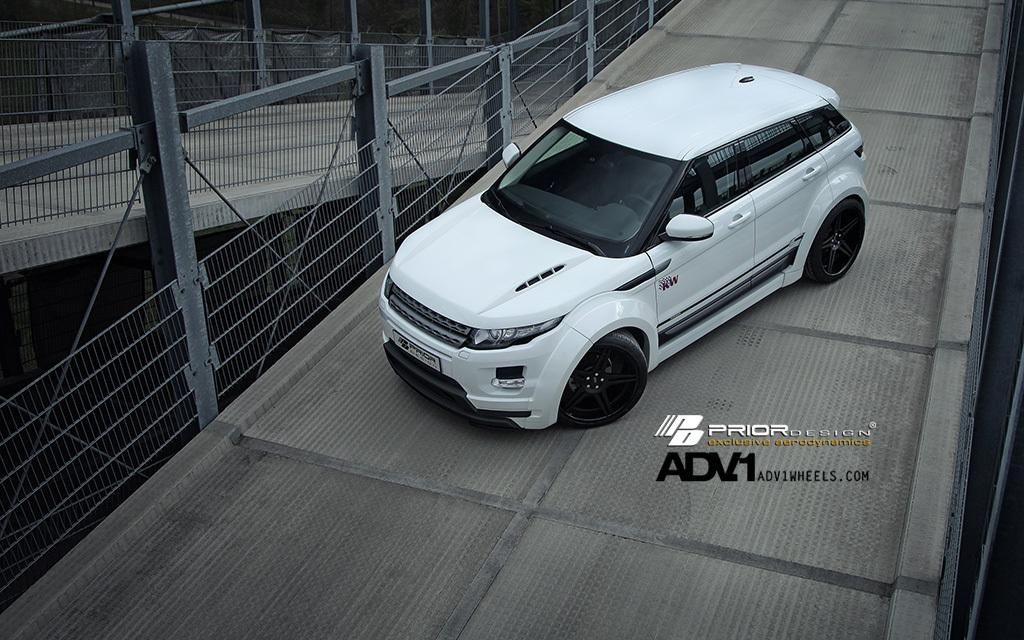What type of vehicle is in the image? There is a white color car in the image. What structures can be seen in the front of the image? There are two bridges in the front of the image. What is located on the left side of the image? There is fencing on the left side of the image. What is present on the right side of the image? There is some text on the right side of the image. What type of creature can be seen cracking the day in the image? There is no creature present in the image, nor is there any reference to cracking or the day. 